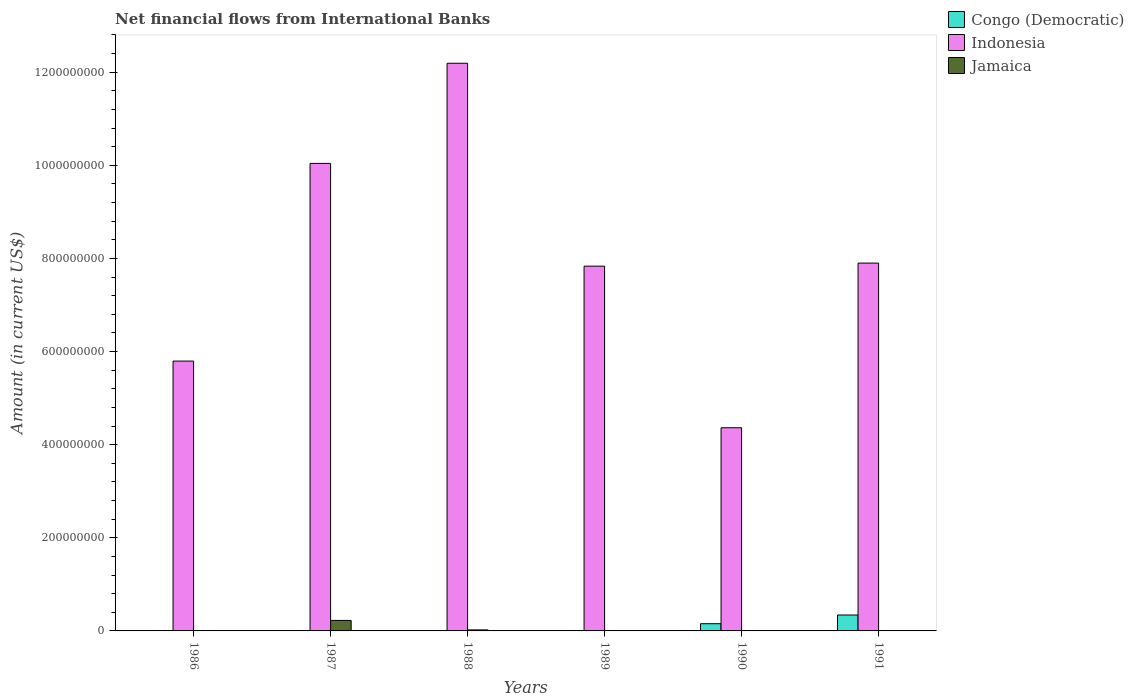Are the number of bars per tick equal to the number of legend labels?
Your answer should be very brief. No. Are the number of bars on each tick of the X-axis equal?
Ensure brevity in your answer.  No. How many bars are there on the 4th tick from the left?
Provide a short and direct response. 1. What is the label of the 4th group of bars from the left?
Ensure brevity in your answer.  1989. In how many cases, is the number of bars for a given year not equal to the number of legend labels?
Provide a succinct answer. 6. What is the net financial aid flows in Indonesia in 1987?
Give a very brief answer. 1.00e+09. Across all years, what is the maximum net financial aid flows in Indonesia?
Provide a succinct answer. 1.22e+09. Across all years, what is the minimum net financial aid flows in Indonesia?
Offer a terse response. 4.36e+08. In which year was the net financial aid flows in Jamaica maximum?
Offer a very short reply. 1987. What is the total net financial aid flows in Jamaica in the graph?
Give a very brief answer. 2.47e+07. What is the difference between the net financial aid flows in Indonesia in 1987 and that in 1991?
Provide a short and direct response. 2.14e+08. What is the difference between the net financial aid flows in Congo (Democratic) in 1988 and the net financial aid flows in Indonesia in 1991?
Ensure brevity in your answer.  -7.90e+08. What is the average net financial aid flows in Congo (Democratic) per year?
Offer a terse response. 8.28e+06. In the year 1988, what is the difference between the net financial aid flows in Jamaica and net financial aid flows in Indonesia?
Your answer should be compact. -1.22e+09. In how many years, is the net financial aid flows in Congo (Democratic) greater than 920000000 US$?
Provide a succinct answer. 0. What is the ratio of the net financial aid flows in Indonesia in 1987 to that in 1988?
Offer a very short reply. 0.82. What is the difference between the highest and the second highest net financial aid flows in Indonesia?
Keep it short and to the point. 2.15e+08. What is the difference between the highest and the lowest net financial aid flows in Congo (Democratic)?
Make the answer very short. 3.42e+07. Is the sum of the net financial aid flows in Indonesia in 1987 and 1990 greater than the maximum net financial aid flows in Congo (Democratic) across all years?
Give a very brief answer. Yes. Is it the case that in every year, the sum of the net financial aid flows in Jamaica and net financial aid flows in Indonesia is greater than the net financial aid flows in Congo (Democratic)?
Make the answer very short. Yes. Are all the bars in the graph horizontal?
Provide a succinct answer. No. How many years are there in the graph?
Your response must be concise. 6. Are the values on the major ticks of Y-axis written in scientific E-notation?
Offer a terse response. No. Does the graph contain any zero values?
Ensure brevity in your answer.  Yes. Does the graph contain grids?
Your response must be concise. No. How are the legend labels stacked?
Your answer should be very brief. Vertical. What is the title of the graph?
Ensure brevity in your answer.  Net financial flows from International Banks. Does "Belarus" appear as one of the legend labels in the graph?
Make the answer very short. No. What is the Amount (in current US$) of Congo (Democratic) in 1986?
Offer a terse response. 0. What is the Amount (in current US$) of Indonesia in 1986?
Make the answer very short. 5.80e+08. What is the Amount (in current US$) of Indonesia in 1987?
Keep it short and to the point. 1.00e+09. What is the Amount (in current US$) of Jamaica in 1987?
Your answer should be compact. 2.25e+07. What is the Amount (in current US$) in Congo (Democratic) in 1988?
Offer a very short reply. 0. What is the Amount (in current US$) in Indonesia in 1988?
Ensure brevity in your answer.  1.22e+09. What is the Amount (in current US$) in Jamaica in 1988?
Give a very brief answer. 2.18e+06. What is the Amount (in current US$) in Congo (Democratic) in 1989?
Your response must be concise. 0. What is the Amount (in current US$) in Indonesia in 1989?
Give a very brief answer. 7.83e+08. What is the Amount (in current US$) in Congo (Democratic) in 1990?
Ensure brevity in your answer.  1.55e+07. What is the Amount (in current US$) of Indonesia in 1990?
Your response must be concise. 4.36e+08. What is the Amount (in current US$) in Jamaica in 1990?
Your answer should be compact. 0. What is the Amount (in current US$) of Congo (Democratic) in 1991?
Your answer should be very brief. 3.42e+07. What is the Amount (in current US$) in Indonesia in 1991?
Provide a short and direct response. 7.90e+08. Across all years, what is the maximum Amount (in current US$) in Congo (Democratic)?
Your answer should be compact. 3.42e+07. Across all years, what is the maximum Amount (in current US$) of Indonesia?
Make the answer very short. 1.22e+09. Across all years, what is the maximum Amount (in current US$) of Jamaica?
Offer a very short reply. 2.25e+07. Across all years, what is the minimum Amount (in current US$) of Indonesia?
Offer a terse response. 4.36e+08. What is the total Amount (in current US$) in Congo (Democratic) in the graph?
Give a very brief answer. 4.97e+07. What is the total Amount (in current US$) in Indonesia in the graph?
Your response must be concise. 4.81e+09. What is the total Amount (in current US$) of Jamaica in the graph?
Your response must be concise. 2.47e+07. What is the difference between the Amount (in current US$) of Indonesia in 1986 and that in 1987?
Ensure brevity in your answer.  -4.25e+08. What is the difference between the Amount (in current US$) in Indonesia in 1986 and that in 1988?
Provide a succinct answer. -6.40e+08. What is the difference between the Amount (in current US$) in Indonesia in 1986 and that in 1989?
Give a very brief answer. -2.04e+08. What is the difference between the Amount (in current US$) in Indonesia in 1986 and that in 1990?
Offer a terse response. 1.43e+08. What is the difference between the Amount (in current US$) of Indonesia in 1986 and that in 1991?
Make the answer very short. -2.10e+08. What is the difference between the Amount (in current US$) of Indonesia in 1987 and that in 1988?
Provide a succinct answer. -2.15e+08. What is the difference between the Amount (in current US$) of Jamaica in 1987 and that in 1988?
Provide a succinct answer. 2.04e+07. What is the difference between the Amount (in current US$) of Indonesia in 1987 and that in 1989?
Give a very brief answer. 2.21e+08. What is the difference between the Amount (in current US$) in Indonesia in 1987 and that in 1990?
Keep it short and to the point. 5.68e+08. What is the difference between the Amount (in current US$) of Indonesia in 1987 and that in 1991?
Ensure brevity in your answer.  2.14e+08. What is the difference between the Amount (in current US$) in Indonesia in 1988 and that in 1989?
Give a very brief answer. 4.36e+08. What is the difference between the Amount (in current US$) of Indonesia in 1988 and that in 1990?
Provide a succinct answer. 7.83e+08. What is the difference between the Amount (in current US$) of Indonesia in 1988 and that in 1991?
Your answer should be very brief. 4.29e+08. What is the difference between the Amount (in current US$) in Indonesia in 1989 and that in 1990?
Keep it short and to the point. 3.47e+08. What is the difference between the Amount (in current US$) in Indonesia in 1989 and that in 1991?
Provide a succinct answer. -6.59e+06. What is the difference between the Amount (in current US$) of Congo (Democratic) in 1990 and that in 1991?
Your response must be concise. -1.87e+07. What is the difference between the Amount (in current US$) in Indonesia in 1990 and that in 1991?
Offer a very short reply. -3.54e+08. What is the difference between the Amount (in current US$) of Indonesia in 1986 and the Amount (in current US$) of Jamaica in 1987?
Provide a succinct answer. 5.57e+08. What is the difference between the Amount (in current US$) in Indonesia in 1986 and the Amount (in current US$) in Jamaica in 1988?
Your answer should be very brief. 5.77e+08. What is the difference between the Amount (in current US$) of Indonesia in 1987 and the Amount (in current US$) of Jamaica in 1988?
Offer a very short reply. 1.00e+09. What is the difference between the Amount (in current US$) in Congo (Democratic) in 1990 and the Amount (in current US$) in Indonesia in 1991?
Ensure brevity in your answer.  -7.75e+08. What is the average Amount (in current US$) in Congo (Democratic) per year?
Offer a terse response. 8.28e+06. What is the average Amount (in current US$) in Indonesia per year?
Your response must be concise. 8.02e+08. What is the average Amount (in current US$) of Jamaica per year?
Offer a terse response. 4.12e+06. In the year 1987, what is the difference between the Amount (in current US$) of Indonesia and Amount (in current US$) of Jamaica?
Give a very brief answer. 9.82e+08. In the year 1988, what is the difference between the Amount (in current US$) in Indonesia and Amount (in current US$) in Jamaica?
Give a very brief answer. 1.22e+09. In the year 1990, what is the difference between the Amount (in current US$) in Congo (Democratic) and Amount (in current US$) in Indonesia?
Offer a very short reply. -4.21e+08. In the year 1991, what is the difference between the Amount (in current US$) in Congo (Democratic) and Amount (in current US$) in Indonesia?
Offer a terse response. -7.56e+08. What is the ratio of the Amount (in current US$) of Indonesia in 1986 to that in 1987?
Offer a terse response. 0.58. What is the ratio of the Amount (in current US$) in Indonesia in 1986 to that in 1988?
Provide a succinct answer. 0.48. What is the ratio of the Amount (in current US$) of Indonesia in 1986 to that in 1989?
Keep it short and to the point. 0.74. What is the ratio of the Amount (in current US$) in Indonesia in 1986 to that in 1990?
Make the answer very short. 1.33. What is the ratio of the Amount (in current US$) of Indonesia in 1986 to that in 1991?
Your response must be concise. 0.73. What is the ratio of the Amount (in current US$) in Indonesia in 1987 to that in 1988?
Provide a short and direct response. 0.82. What is the ratio of the Amount (in current US$) of Jamaica in 1987 to that in 1988?
Your response must be concise. 10.37. What is the ratio of the Amount (in current US$) of Indonesia in 1987 to that in 1989?
Your answer should be very brief. 1.28. What is the ratio of the Amount (in current US$) of Indonesia in 1987 to that in 1990?
Keep it short and to the point. 2.3. What is the ratio of the Amount (in current US$) in Indonesia in 1987 to that in 1991?
Give a very brief answer. 1.27. What is the ratio of the Amount (in current US$) of Indonesia in 1988 to that in 1989?
Ensure brevity in your answer.  1.56. What is the ratio of the Amount (in current US$) in Indonesia in 1988 to that in 1990?
Keep it short and to the point. 2.79. What is the ratio of the Amount (in current US$) in Indonesia in 1988 to that in 1991?
Provide a succinct answer. 1.54. What is the ratio of the Amount (in current US$) of Indonesia in 1989 to that in 1990?
Provide a succinct answer. 1.8. What is the ratio of the Amount (in current US$) of Indonesia in 1989 to that in 1991?
Your answer should be very brief. 0.99. What is the ratio of the Amount (in current US$) in Congo (Democratic) in 1990 to that in 1991?
Offer a very short reply. 0.45. What is the ratio of the Amount (in current US$) in Indonesia in 1990 to that in 1991?
Make the answer very short. 0.55. What is the difference between the highest and the second highest Amount (in current US$) in Indonesia?
Ensure brevity in your answer.  2.15e+08. What is the difference between the highest and the lowest Amount (in current US$) in Congo (Democratic)?
Your answer should be compact. 3.42e+07. What is the difference between the highest and the lowest Amount (in current US$) of Indonesia?
Make the answer very short. 7.83e+08. What is the difference between the highest and the lowest Amount (in current US$) in Jamaica?
Provide a succinct answer. 2.25e+07. 